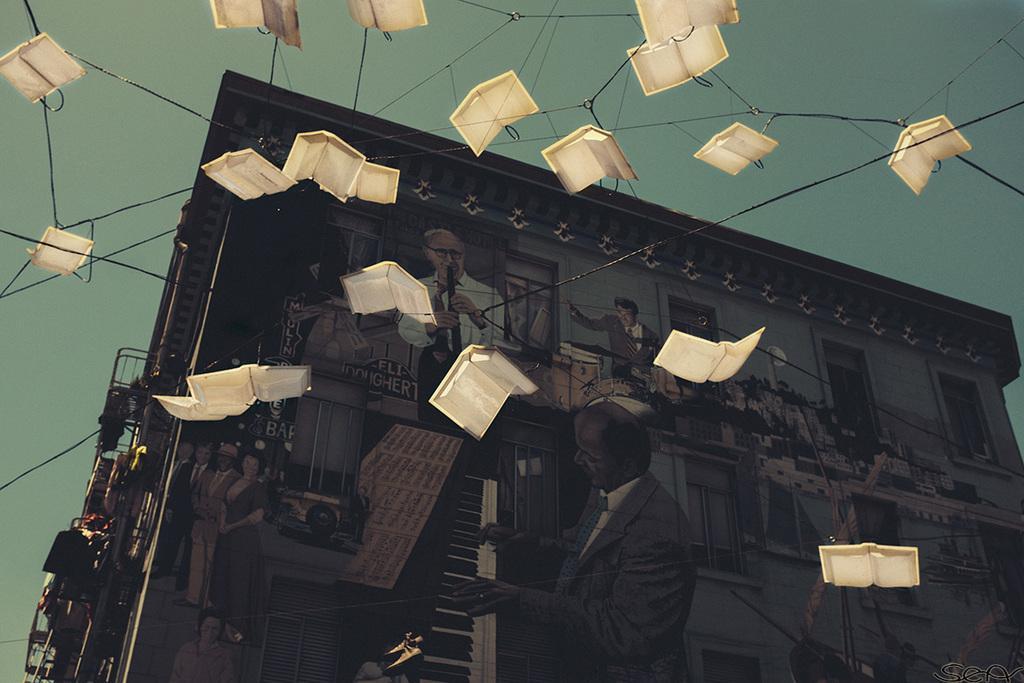How would you summarize this image in a sentence or two? In this image we can see a building, in front of the building there are few decorative items hanging in the air with strings attached to it. 